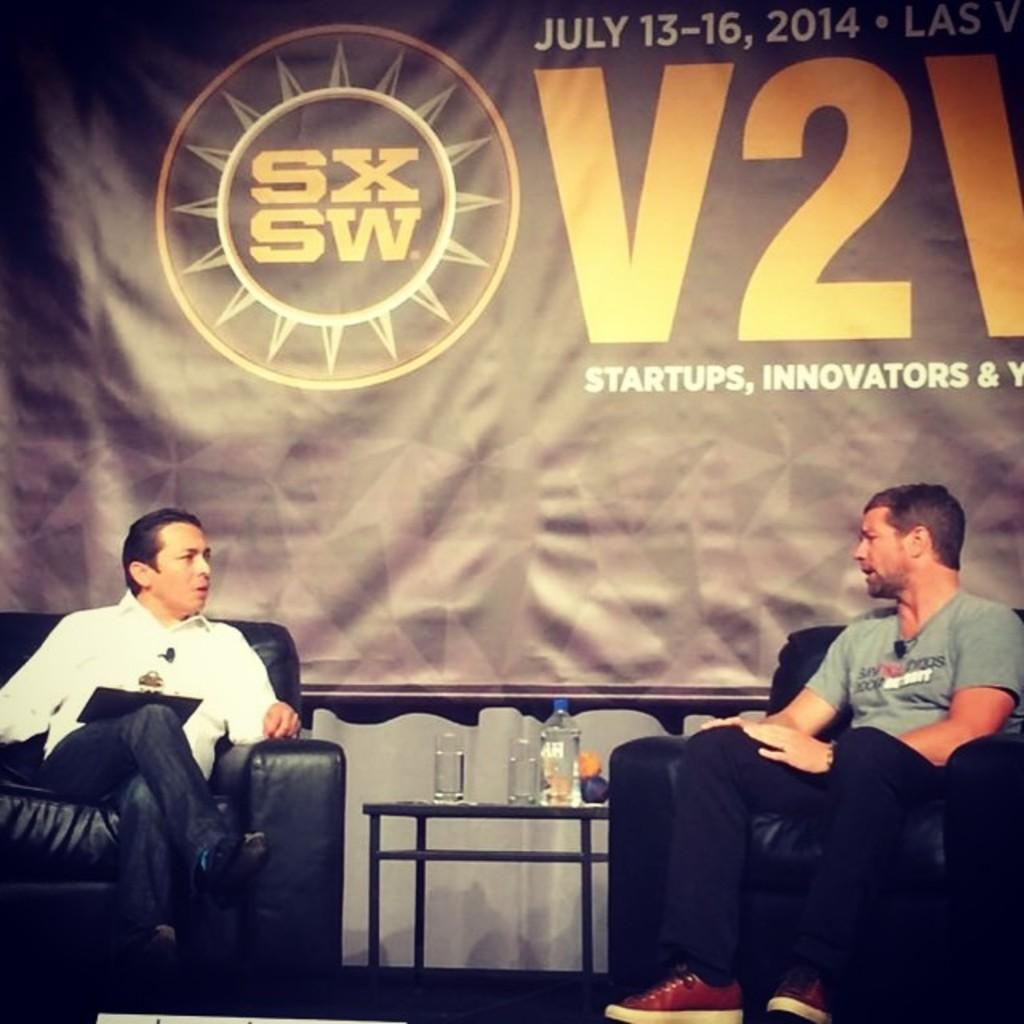How many people are sitting on the sofas in the image? There are two persons sitting on the sofas in the image. What objects can be seen on the table? There are glasses and a bottle on the table in the image. What is hanging at the back of the scene? There is a banner at the back in the image. What is written or depicted on the banner? There is text on the banner in the image. What type of mist is present in the image? There is no mist present in the image. What process is being depicted in the image? The image does not depict a specific process; it shows two people sitting on sofas with glasses, a bottle, and a banner in the background. 